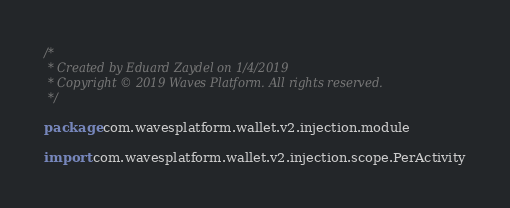<code> <loc_0><loc_0><loc_500><loc_500><_Kotlin_>/*
 * Created by Eduard Zaydel on 1/4/2019
 * Copyright © 2019 Waves Platform. All rights reserved.
 */

package com.wavesplatform.wallet.v2.injection.module

import com.wavesplatform.wallet.v2.injection.scope.PerActivity</code> 